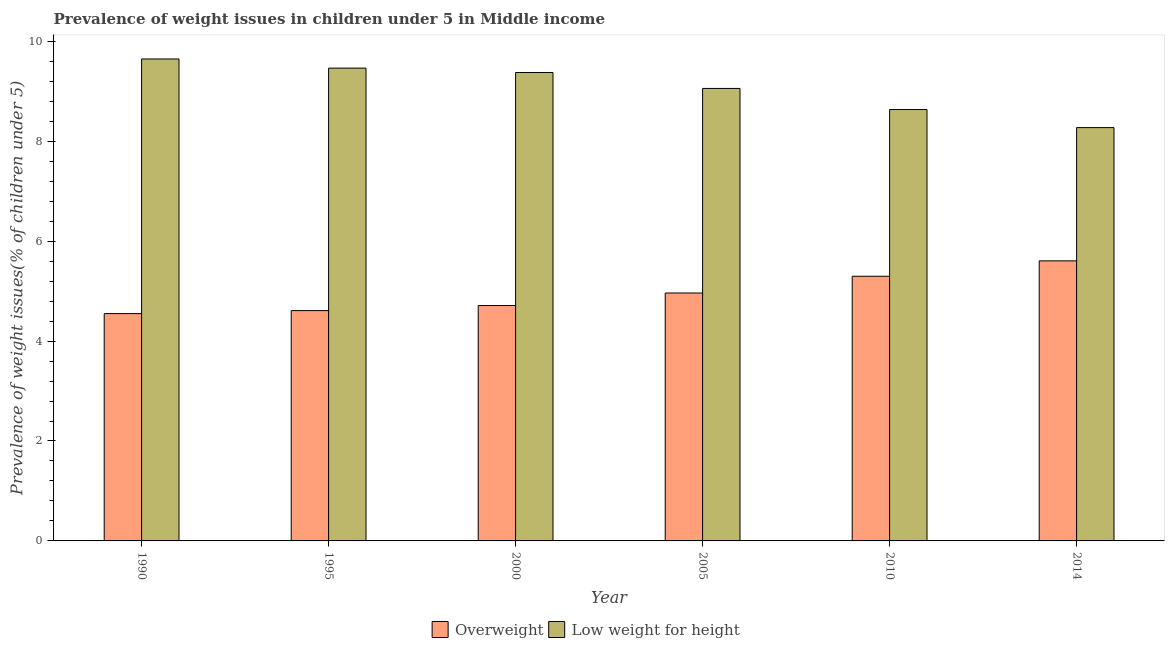How many groups of bars are there?
Your answer should be compact. 6. Are the number of bars on each tick of the X-axis equal?
Your response must be concise. Yes. What is the label of the 2nd group of bars from the left?
Offer a very short reply. 1995. In how many cases, is the number of bars for a given year not equal to the number of legend labels?
Make the answer very short. 0. What is the percentage of overweight children in 2000?
Ensure brevity in your answer.  4.71. Across all years, what is the maximum percentage of overweight children?
Your answer should be very brief. 5.6. Across all years, what is the minimum percentage of underweight children?
Offer a very short reply. 8.27. In which year was the percentage of underweight children maximum?
Ensure brevity in your answer.  1990. In which year was the percentage of overweight children minimum?
Your answer should be very brief. 1990. What is the total percentage of overweight children in the graph?
Your answer should be compact. 29.73. What is the difference between the percentage of overweight children in 1995 and that in 2000?
Give a very brief answer. -0.1. What is the difference between the percentage of overweight children in 1990 and the percentage of underweight children in 2005?
Give a very brief answer. -0.41. What is the average percentage of underweight children per year?
Your response must be concise. 9.07. In the year 2014, what is the difference between the percentage of overweight children and percentage of underweight children?
Provide a short and direct response. 0. In how many years, is the percentage of overweight children greater than 0.4 %?
Ensure brevity in your answer.  6. What is the ratio of the percentage of underweight children in 1990 to that in 2005?
Keep it short and to the point. 1.07. Is the difference between the percentage of overweight children in 1995 and 2000 greater than the difference between the percentage of underweight children in 1995 and 2000?
Give a very brief answer. No. What is the difference between the highest and the second highest percentage of underweight children?
Offer a very short reply. 0.18. What is the difference between the highest and the lowest percentage of overweight children?
Your answer should be compact. 1.06. In how many years, is the percentage of overweight children greater than the average percentage of overweight children taken over all years?
Offer a very short reply. 3. What does the 1st bar from the left in 2000 represents?
Your response must be concise. Overweight. What does the 1st bar from the right in 1990 represents?
Make the answer very short. Low weight for height. How many bars are there?
Offer a very short reply. 12. Are all the bars in the graph horizontal?
Your response must be concise. No. How many years are there in the graph?
Provide a succinct answer. 6. What is the difference between two consecutive major ticks on the Y-axis?
Provide a succinct answer. 2. Does the graph contain grids?
Provide a succinct answer. No. How many legend labels are there?
Provide a succinct answer. 2. What is the title of the graph?
Provide a succinct answer. Prevalence of weight issues in children under 5 in Middle income. What is the label or title of the Y-axis?
Offer a terse response. Prevalence of weight issues(% of children under 5). What is the Prevalence of weight issues(% of children under 5) of Overweight in 1990?
Offer a very short reply. 4.55. What is the Prevalence of weight issues(% of children under 5) of Low weight for height in 1990?
Provide a succinct answer. 9.65. What is the Prevalence of weight issues(% of children under 5) of Overweight in 1995?
Ensure brevity in your answer.  4.61. What is the Prevalence of weight issues(% of children under 5) of Low weight for height in 1995?
Offer a very short reply. 9.46. What is the Prevalence of weight issues(% of children under 5) in Overweight in 2000?
Provide a succinct answer. 4.71. What is the Prevalence of weight issues(% of children under 5) in Low weight for height in 2000?
Your answer should be compact. 9.37. What is the Prevalence of weight issues(% of children under 5) of Overweight in 2005?
Provide a succinct answer. 4.96. What is the Prevalence of weight issues(% of children under 5) in Low weight for height in 2005?
Provide a short and direct response. 9.06. What is the Prevalence of weight issues(% of children under 5) of Overweight in 2010?
Ensure brevity in your answer.  5.3. What is the Prevalence of weight issues(% of children under 5) in Low weight for height in 2010?
Your response must be concise. 8.63. What is the Prevalence of weight issues(% of children under 5) in Overweight in 2014?
Provide a succinct answer. 5.6. What is the Prevalence of weight issues(% of children under 5) in Low weight for height in 2014?
Provide a short and direct response. 8.27. Across all years, what is the maximum Prevalence of weight issues(% of children under 5) of Overweight?
Offer a terse response. 5.6. Across all years, what is the maximum Prevalence of weight issues(% of children under 5) in Low weight for height?
Your response must be concise. 9.65. Across all years, what is the minimum Prevalence of weight issues(% of children under 5) in Overweight?
Your answer should be very brief. 4.55. Across all years, what is the minimum Prevalence of weight issues(% of children under 5) of Low weight for height?
Ensure brevity in your answer.  8.27. What is the total Prevalence of weight issues(% of children under 5) of Overweight in the graph?
Give a very brief answer. 29.73. What is the total Prevalence of weight issues(% of children under 5) of Low weight for height in the graph?
Provide a succinct answer. 54.44. What is the difference between the Prevalence of weight issues(% of children under 5) in Overweight in 1990 and that in 1995?
Provide a short and direct response. -0.06. What is the difference between the Prevalence of weight issues(% of children under 5) in Low weight for height in 1990 and that in 1995?
Offer a terse response. 0.18. What is the difference between the Prevalence of weight issues(% of children under 5) in Overweight in 1990 and that in 2000?
Provide a succinct answer. -0.16. What is the difference between the Prevalence of weight issues(% of children under 5) of Low weight for height in 1990 and that in 2000?
Provide a succinct answer. 0.27. What is the difference between the Prevalence of weight issues(% of children under 5) in Overweight in 1990 and that in 2005?
Your answer should be compact. -0.41. What is the difference between the Prevalence of weight issues(% of children under 5) in Low weight for height in 1990 and that in 2005?
Your answer should be very brief. 0.59. What is the difference between the Prevalence of weight issues(% of children under 5) of Overweight in 1990 and that in 2010?
Provide a short and direct response. -0.75. What is the difference between the Prevalence of weight issues(% of children under 5) in Low weight for height in 1990 and that in 2010?
Give a very brief answer. 1.01. What is the difference between the Prevalence of weight issues(% of children under 5) in Overweight in 1990 and that in 2014?
Make the answer very short. -1.06. What is the difference between the Prevalence of weight issues(% of children under 5) of Low weight for height in 1990 and that in 2014?
Your response must be concise. 1.37. What is the difference between the Prevalence of weight issues(% of children under 5) in Overweight in 1995 and that in 2000?
Keep it short and to the point. -0.1. What is the difference between the Prevalence of weight issues(% of children under 5) of Low weight for height in 1995 and that in 2000?
Your response must be concise. 0.09. What is the difference between the Prevalence of weight issues(% of children under 5) of Overweight in 1995 and that in 2005?
Provide a succinct answer. -0.35. What is the difference between the Prevalence of weight issues(% of children under 5) of Low weight for height in 1995 and that in 2005?
Keep it short and to the point. 0.41. What is the difference between the Prevalence of weight issues(% of children under 5) of Overweight in 1995 and that in 2010?
Make the answer very short. -0.69. What is the difference between the Prevalence of weight issues(% of children under 5) of Low weight for height in 1995 and that in 2010?
Keep it short and to the point. 0.83. What is the difference between the Prevalence of weight issues(% of children under 5) of Overweight in 1995 and that in 2014?
Make the answer very short. -1. What is the difference between the Prevalence of weight issues(% of children under 5) of Low weight for height in 1995 and that in 2014?
Provide a short and direct response. 1.19. What is the difference between the Prevalence of weight issues(% of children under 5) of Overweight in 2000 and that in 2005?
Give a very brief answer. -0.25. What is the difference between the Prevalence of weight issues(% of children under 5) in Low weight for height in 2000 and that in 2005?
Provide a short and direct response. 0.32. What is the difference between the Prevalence of weight issues(% of children under 5) in Overweight in 2000 and that in 2010?
Make the answer very short. -0.59. What is the difference between the Prevalence of weight issues(% of children under 5) in Low weight for height in 2000 and that in 2010?
Give a very brief answer. 0.74. What is the difference between the Prevalence of weight issues(% of children under 5) of Overweight in 2000 and that in 2014?
Offer a terse response. -0.89. What is the difference between the Prevalence of weight issues(% of children under 5) of Low weight for height in 2000 and that in 2014?
Offer a very short reply. 1.1. What is the difference between the Prevalence of weight issues(% of children under 5) in Overweight in 2005 and that in 2010?
Your response must be concise. -0.34. What is the difference between the Prevalence of weight issues(% of children under 5) in Low weight for height in 2005 and that in 2010?
Provide a short and direct response. 0.42. What is the difference between the Prevalence of weight issues(% of children under 5) in Overweight in 2005 and that in 2014?
Ensure brevity in your answer.  -0.64. What is the difference between the Prevalence of weight issues(% of children under 5) in Low weight for height in 2005 and that in 2014?
Ensure brevity in your answer.  0.78. What is the difference between the Prevalence of weight issues(% of children under 5) of Overweight in 2010 and that in 2014?
Provide a short and direct response. -0.31. What is the difference between the Prevalence of weight issues(% of children under 5) in Low weight for height in 2010 and that in 2014?
Your answer should be compact. 0.36. What is the difference between the Prevalence of weight issues(% of children under 5) in Overweight in 1990 and the Prevalence of weight issues(% of children under 5) in Low weight for height in 1995?
Ensure brevity in your answer.  -4.91. What is the difference between the Prevalence of weight issues(% of children under 5) in Overweight in 1990 and the Prevalence of weight issues(% of children under 5) in Low weight for height in 2000?
Your response must be concise. -4.83. What is the difference between the Prevalence of weight issues(% of children under 5) of Overweight in 1990 and the Prevalence of weight issues(% of children under 5) of Low weight for height in 2005?
Your answer should be compact. -4.51. What is the difference between the Prevalence of weight issues(% of children under 5) of Overweight in 1990 and the Prevalence of weight issues(% of children under 5) of Low weight for height in 2010?
Make the answer very short. -4.08. What is the difference between the Prevalence of weight issues(% of children under 5) in Overweight in 1990 and the Prevalence of weight issues(% of children under 5) in Low weight for height in 2014?
Provide a short and direct response. -3.72. What is the difference between the Prevalence of weight issues(% of children under 5) of Overweight in 1995 and the Prevalence of weight issues(% of children under 5) of Low weight for height in 2000?
Provide a succinct answer. -4.77. What is the difference between the Prevalence of weight issues(% of children under 5) of Overweight in 1995 and the Prevalence of weight issues(% of children under 5) of Low weight for height in 2005?
Provide a succinct answer. -4.45. What is the difference between the Prevalence of weight issues(% of children under 5) in Overweight in 1995 and the Prevalence of weight issues(% of children under 5) in Low weight for height in 2010?
Ensure brevity in your answer.  -4.02. What is the difference between the Prevalence of weight issues(% of children under 5) in Overweight in 1995 and the Prevalence of weight issues(% of children under 5) in Low weight for height in 2014?
Your answer should be compact. -3.66. What is the difference between the Prevalence of weight issues(% of children under 5) in Overweight in 2000 and the Prevalence of weight issues(% of children under 5) in Low weight for height in 2005?
Give a very brief answer. -4.34. What is the difference between the Prevalence of weight issues(% of children under 5) of Overweight in 2000 and the Prevalence of weight issues(% of children under 5) of Low weight for height in 2010?
Provide a short and direct response. -3.92. What is the difference between the Prevalence of weight issues(% of children under 5) in Overweight in 2000 and the Prevalence of weight issues(% of children under 5) in Low weight for height in 2014?
Provide a succinct answer. -3.56. What is the difference between the Prevalence of weight issues(% of children under 5) of Overweight in 2005 and the Prevalence of weight issues(% of children under 5) of Low weight for height in 2010?
Offer a terse response. -3.67. What is the difference between the Prevalence of weight issues(% of children under 5) of Overweight in 2005 and the Prevalence of weight issues(% of children under 5) of Low weight for height in 2014?
Offer a terse response. -3.31. What is the difference between the Prevalence of weight issues(% of children under 5) in Overweight in 2010 and the Prevalence of weight issues(% of children under 5) in Low weight for height in 2014?
Keep it short and to the point. -2.98. What is the average Prevalence of weight issues(% of children under 5) of Overweight per year?
Keep it short and to the point. 4.96. What is the average Prevalence of weight issues(% of children under 5) of Low weight for height per year?
Give a very brief answer. 9.07. In the year 1990, what is the difference between the Prevalence of weight issues(% of children under 5) of Overweight and Prevalence of weight issues(% of children under 5) of Low weight for height?
Offer a very short reply. -5.1. In the year 1995, what is the difference between the Prevalence of weight issues(% of children under 5) in Overweight and Prevalence of weight issues(% of children under 5) in Low weight for height?
Your answer should be compact. -4.85. In the year 2000, what is the difference between the Prevalence of weight issues(% of children under 5) of Overweight and Prevalence of weight issues(% of children under 5) of Low weight for height?
Give a very brief answer. -4.66. In the year 2005, what is the difference between the Prevalence of weight issues(% of children under 5) in Overweight and Prevalence of weight issues(% of children under 5) in Low weight for height?
Your response must be concise. -4.09. In the year 2010, what is the difference between the Prevalence of weight issues(% of children under 5) in Overweight and Prevalence of weight issues(% of children under 5) in Low weight for height?
Your answer should be very brief. -3.34. In the year 2014, what is the difference between the Prevalence of weight issues(% of children under 5) of Overweight and Prevalence of weight issues(% of children under 5) of Low weight for height?
Offer a terse response. -2.67. What is the ratio of the Prevalence of weight issues(% of children under 5) of Low weight for height in 1990 to that in 1995?
Provide a succinct answer. 1.02. What is the ratio of the Prevalence of weight issues(% of children under 5) of Overweight in 1990 to that in 2000?
Give a very brief answer. 0.97. What is the ratio of the Prevalence of weight issues(% of children under 5) in Low weight for height in 1990 to that in 2000?
Offer a very short reply. 1.03. What is the ratio of the Prevalence of weight issues(% of children under 5) in Overweight in 1990 to that in 2005?
Offer a terse response. 0.92. What is the ratio of the Prevalence of weight issues(% of children under 5) in Low weight for height in 1990 to that in 2005?
Offer a very short reply. 1.07. What is the ratio of the Prevalence of weight issues(% of children under 5) in Overweight in 1990 to that in 2010?
Offer a terse response. 0.86. What is the ratio of the Prevalence of weight issues(% of children under 5) of Low weight for height in 1990 to that in 2010?
Your answer should be compact. 1.12. What is the ratio of the Prevalence of weight issues(% of children under 5) of Overweight in 1990 to that in 2014?
Offer a very short reply. 0.81. What is the ratio of the Prevalence of weight issues(% of children under 5) of Low weight for height in 1990 to that in 2014?
Ensure brevity in your answer.  1.17. What is the ratio of the Prevalence of weight issues(% of children under 5) of Overweight in 1995 to that in 2000?
Your answer should be compact. 0.98. What is the ratio of the Prevalence of weight issues(% of children under 5) in Low weight for height in 1995 to that in 2000?
Provide a short and direct response. 1.01. What is the ratio of the Prevalence of weight issues(% of children under 5) of Overweight in 1995 to that in 2005?
Make the answer very short. 0.93. What is the ratio of the Prevalence of weight issues(% of children under 5) in Low weight for height in 1995 to that in 2005?
Your answer should be very brief. 1.04. What is the ratio of the Prevalence of weight issues(% of children under 5) of Overweight in 1995 to that in 2010?
Your answer should be compact. 0.87. What is the ratio of the Prevalence of weight issues(% of children under 5) in Low weight for height in 1995 to that in 2010?
Your response must be concise. 1.1. What is the ratio of the Prevalence of weight issues(% of children under 5) in Overweight in 1995 to that in 2014?
Your answer should be compact. 0.82. What is the ratio of the Prevalence of weight issues(% of children under 5) in Low weight for height in 1995 to that in 2014?
Keep it short and to the point. 1.14. What is the ratio of the Prevalence of weight issues(% of children under 5) in Overweight in 2000 to that in 2005?
Give a very brief answer. 0.95. What is the ratio of the Prevalence of weight issues(% of children under 5) of Low weight for height in 2000 to that in 2005?
Make the answer very short. 1.04. What is the ratio of the Prevalence of weight issues(% of children under 5) of Overweight in 2000 to that in 2010?
Your response must be concise. 0.89. What is the ratio of the Prevalence of weight issues(% of children under 5) of Low weight for height in 2000 to that in 2010?
Your answer should be compact. 1.09. What is the ratio of the Prevalence of weight issues(% of children under 5) in Overweight in 2000 to that in 2014?
Provide a succinct answer. 0.84. What is the ratio of the Prevalence of weight issues(% of children under 5) in Low weight for height in 2000 to that in 2014?
Ensure brevity in your answer.  1.13. What is the ratio of the Prevalence of weight issues(% of children under 5) in Overweight in 2005 to that in 2010?
Your answer should be very brief. 0.94. What is the ratio of the Prevalence of weight issues(% of children under 5) of Low weight for height in 2005 to that in 2010?
Your response must be concise. 1.05. What is the ratio of the Prevalence of weight issues(% of children under 5) in Overweight in 2005 to that in 2014?
Your answer should be compact. 0.89. What is the ratio of the Prevalence of weight issues(% of children under 5) in Low weight for height in 2005 to that in 2014?
Keep it short and to the point. 1.09. What is the ratio of the Prevalence of weight issues(% of children under 5) in Overweight in 2010 to that in 2014?
Make the answer very short. 0.95. What is the ratio of the Prevalence of weight issues(% of children under 5) of Low weight for height in 2010 to that in 2014?
Keep it short and to the point. 1.04. What is the difference between the highest and the second highest Prevalence of weight issues(% of children under 5) of Overweight?
Keep it short and to the point. 0.31. What is the difference between the highest and the second highest Prevalence of weight issues(% of children under 5) of Low weight for height?
Offer a very short reply. 0.18. What is the difference between the highest and the lowest Prevalence of weight issues(% of children under 5) of Overweight?
Ensure brevity in your answer.  1.06. What is the difference between the highest and the lowest Prevalence of weight issues(% of children under 5) in Low weight for height?
Give a very brief answer. 1.37. 